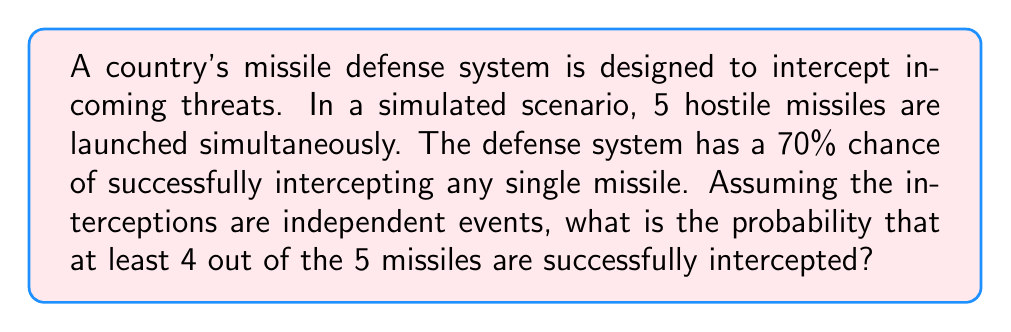Show me your answer to this math problem. To solve this problem, we'll use the concept of binomial probability. Let's break it down step-by-step:

1) We have n = 5 trials (missiles), and we want the probability of at least 4 successes.

2) The probability of success for each trial is p = 0.70 (70% chance of interception).

3) We need to calculate P(X ≥ 4), where X is the number of successful interceptions.

4) This is equivalent to 1 - P(X < 4) = 1 - [P(X = 0) + P(X = 1) + P(X = 2) + P(X = 3)]

5) We can use the binomial probability formula:

   $$P(X = k) = \binom{n}{k} p^k (1-p)^{n-k}$$

   where $\binom{n}{k}$ is the binomial coefficient.

6) Let's calculate each probability:

   P(X = 5) = $\binom{5}{5} (0.70)^5 (0.30)^0 = 1 \cdot 0.16807 \cdot 1 = 0.16807$

   P(X = 4) = $\binom{5}{4} (0.70)^4 (0.30)^1 = 5 \cdot 0.2401 \cdot 0.30 = 0.36015$

7) Therefore, P(X ≥ 4) = P(X = 4) + P(X = 5) = 0.36015 + 0.16807 = 0.52822

8) Convert to a percentage: 0.52822 * 100 = 52.822%
Answer: The probability that at least 4 out of the 5 missiles are successfully intercepted is approximately 52.82%. 